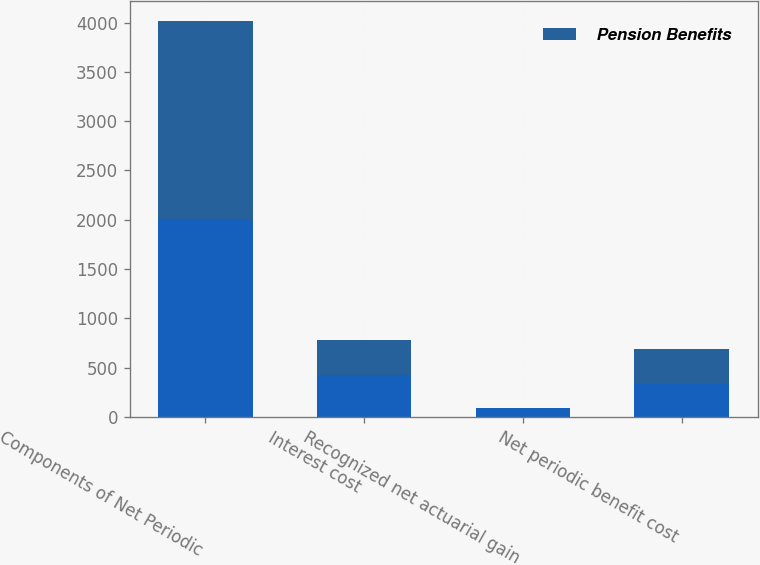<chart> <loc_0><loc_0><loc_500><loc_500><stacked_bar_chart><ecel><fcel>Components of Net Periodic<fcel>Interest cost<fcel>Recognized net actuarial gain<fcel>Net periodic benefit cost<nl><fcel>nan<fcel>2008<fcel>424<fcel>93<fcel>331<nl><fcel>Pension Benefits<fcel>2006<fcel>355<fcel>1<fcel>354<nl></chart> 